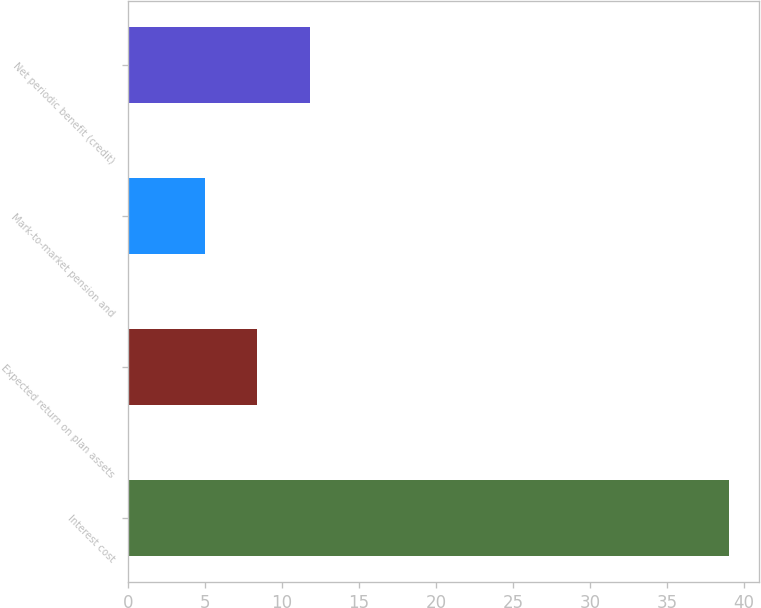Convert chart to OTSL. <chart><loc_0><loc_0><loc_500><loc_500><bar_chart><fcel>Interest cost<fcel>Expected return on plan assets<fcel>Mark-to-market pension and<fcel>Net periodic benefit (credit)<nl><fcel>39<fcel>8.4<fcel>5<fcel>11.8<nl></chart> 